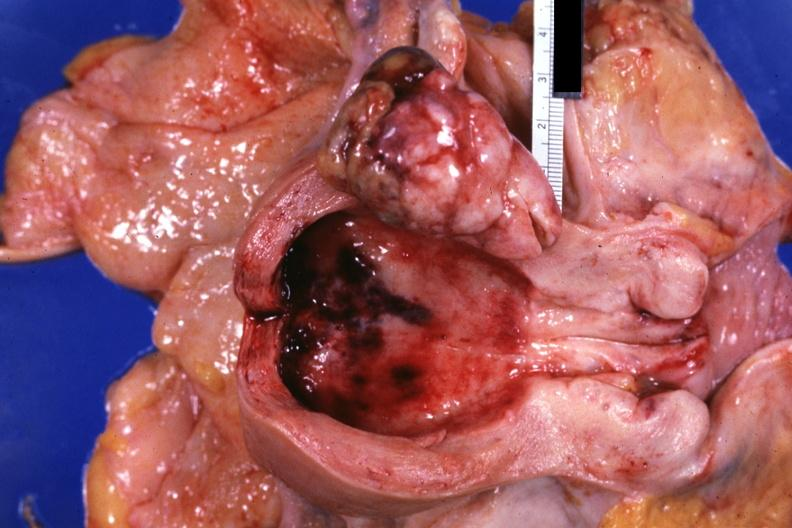s female reproductive present?
Answer the question using a single word or phrase. Yes 